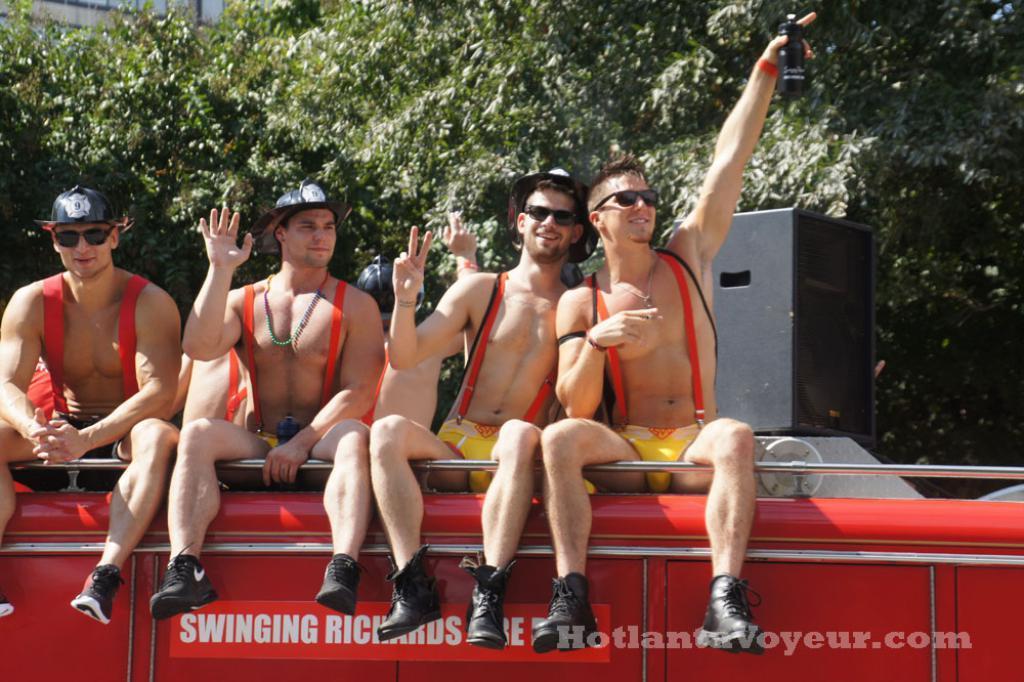In one or two sentences, can you explain what this image depicts? In this image there are four persons sitting on a vehicle, on that vehicle there is some text, in the background there are trees and a box, in the bottom right there is some text. 